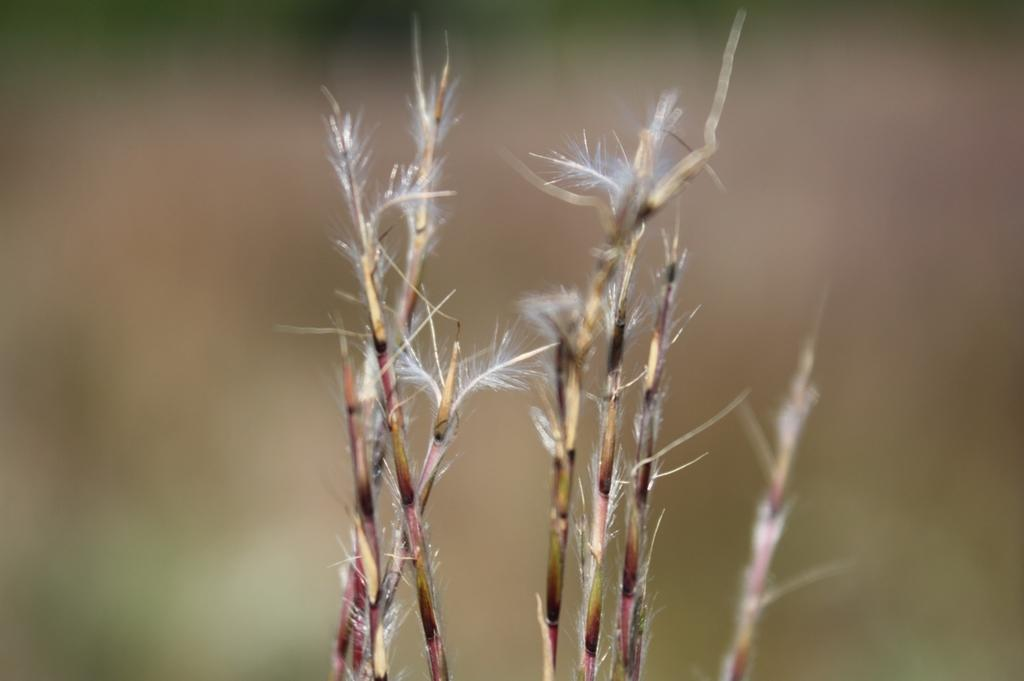What type of grass can be seen in the image? There is bluestem grass in the image. How would you describe the background of the image? The background of the image is blurred. How many leaves are on the bluestem grass in the image? There is no mention of leaves on the bluestem grass in the image, as bluestem grass is a type of grass and not a leafy plant. 